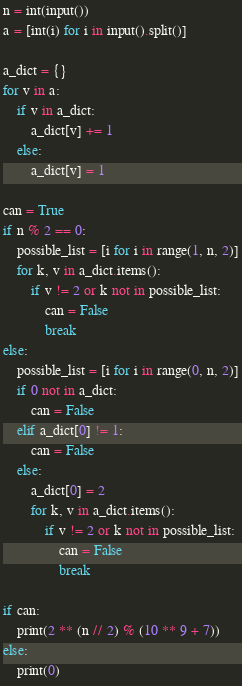Convert code to text. <code><loc_0><loc_0><loc_500><loc_500><_Python_>n = int(input())
a = [int(i) for i in input().split()]

a_dict = {}
for v in a:
    if v in a_dict:
        a_dict[v] += 1
    else:
        a_dict[v] = 1

can = True
if n % 2 == 0:
    possible_list = [i for i in range(1, n, 2)]
    for k, v in a_dict.items():
        if v != 2 or k not in possible_list:
            can = False
            break
else:
    possible_list = [i for i in range(0, n, 2)]
    if 0 not in a_dict:
        can = False
    elif a_dict[0] != 1:
        can = False
    else:
        a_dict[0] = 2
        for k, v in a_dict.items():
            if v != 2 or k not in possible_list:
                can = False
                break

if can:
    print(2 ** (n // 2) % (10 ** 9 + 7))
else:
    print(0)
</code> 